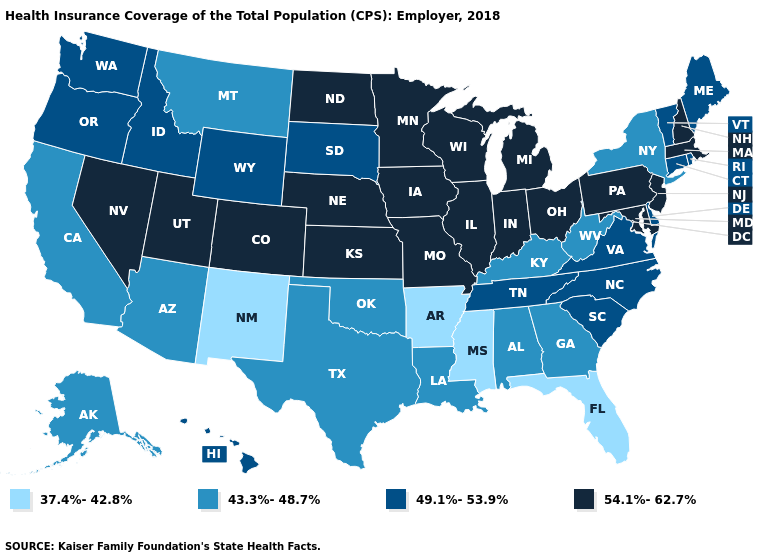Which states have the lowest value in the Northeast?
Short answer required. New York. Which states have the highest value in the USA?
Write a very short answer. Colorado, Illinois, Indiana, Iowa, Kansas, Maryland, Massachusetts, Michigan, Minnesota, Missouri, Nebraska, Nevada, New Hampshire, New Jersey, North Dakota, Ohio, Pennsylvania, Utah, Wisconsin. What is the value of South Carolina?
Give a very brief answer. 49.1%-53.9%. Among the states that border Mississippi , which have the highest value?
Give a very brief answer. Tennessee. Does New Mexico have the lowest value in the West?
Quick response, please. Yes. What is the lowest value in states that border Nebraska?
Keep it brief. 49.1%-53.9%. What is the value of North Dakota?
Write a very short answer. 54.1%-62.7%. What is the lowest value in the USA?
Quick response, please. 37.4%-42.8%. Does Arkansas have a higher value than Oregon?
Write a very short answer. No. Does Texas have the lowest value in the USA?
Quick response, please. No. What is the lowest value in the USA?
Quick response, please. 37.4%-42.8%. Does Colorado have a higher value than Ohio?
Give a very brief answer. No. What is the value of Florida?
Short answer required. 37.4%-42.8%. Name the states that have a value in the range 54.1%-62.7%?
Give a very brief answer. Colorado, Illinois, Indiana, Iowa, Kansas, Maryland, Massachusetts, Michigan, Minnesota, Missouri, Nebraska, Nevada, New Hampshire, New Jersey, North Dakota, Ohio, Pennsylvania, Utah, Wisconsin. What is the value of Nebraska?
Be succinct. 54.1%-62.7%. 